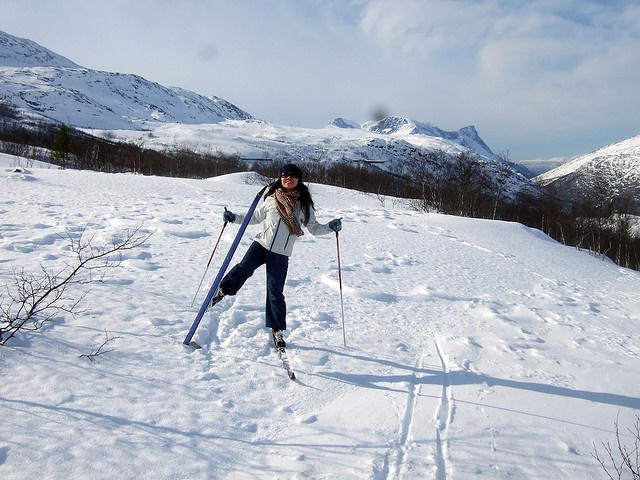Describe the objects in this image and their specific colors. I can see people in lightgray, black, darkgray, and gray tones and skis in lightgray, navy, and blue tones in this image. 